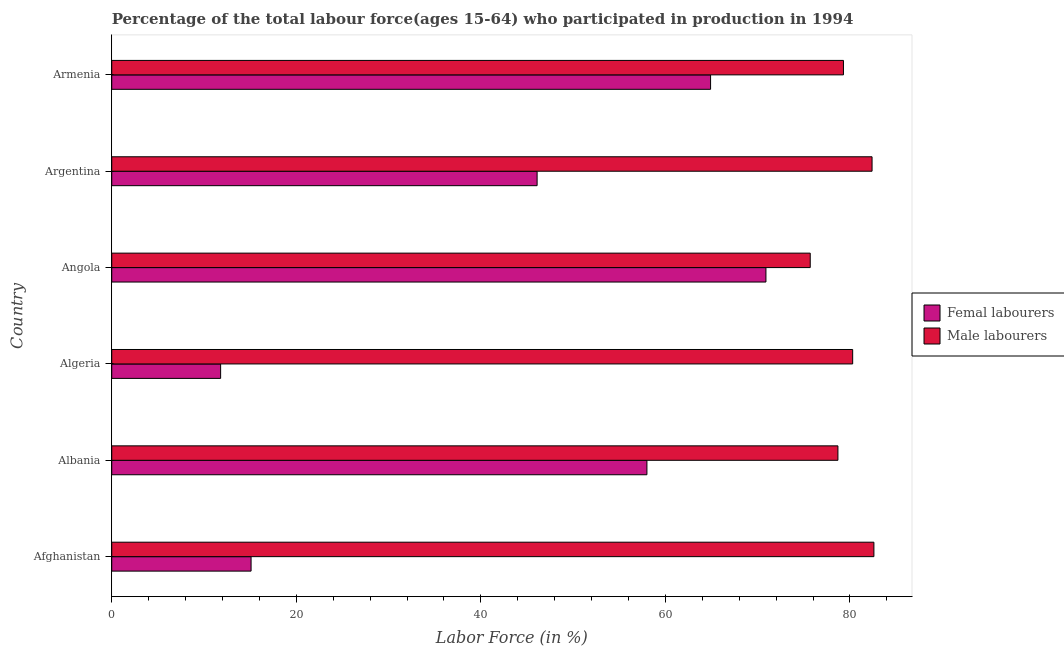Are the number of bars on each tick of the Y-axis equal?
Make the answer very short. Yes. How many bars are there on the 2nd tick from the top?
Give a very brief answer. 2. What is the label of the 3rd group of bars from the top?
Keep it short and to the point. Angola. What is the percentage of male labour force in Afghanistan?
Offer a terse response. 82.6. Across all countries, what is the maximum percentage of male labour force?
Ensure brevity in your answer.  82.6. Across all countries, what is the minimum percentage of male labour force?
Your answer should be compact. 75.7. In which country was the percentage of female labor force maximum?
Offer a terse response. Angola. In which country was the percentage of male labour force minimum?
Your answer should be compact. Angola. What is the total percentage of female labor force in the graph?
Keep it short and to the point. 266.8. What is the difference between the percentage of male labour force in Albania and that in Angola?
Give a very brief answer. 3. What is the difference between the percentage of female labor force in Argentina and the percentage of male labour force in Armenia?
Make the answer very short. -33.2. What is the average percentage of female labor force per country?
Offer a terse response. 44.47. What is the difference between the percentage of female labor force and percentage of male labour force in Argentina?
Keep it short and to the point. -36.3. What is the ratio of the percentage of female labor force in Algeria to that in Armenia?
Your response must be concise. 0.18. Is the percentage of male labour force in Algeria less than that in Argentina?
Ensure brevity in your answer.  Yes. Is the difference between the percentage of male labour force in Algeria and Armenia greater than the difference between the percentage of female labor force in Algeria and Armenia?
Offer a very short reply. Yes. What is the difference between the highest and the lowest percentage of male labour force?
Make the answer very short. 6.9. In how many countries, is the percentage of male labour force greater than the average percentage of male labour force taken over all countries?
Give a very brief answer. 3. What does the 2nd bar from the top in Argentina represents?
Give a very brief answer. Femal labourers. What does the 2nd bar from the bottom in Afghanistan represents?
Ensure brevity in your answer.  Male labourers. Are the values on the major ticks of X-axis written in scientific E-notation?
Offer a very short reply. No. How are the legend labels stacked?
Make the answer very short. Vertical. What is the title of the graph?
Offer a very short reply. Percentage of the total labour force(ages 15-64) who participated in production in 1994. Does "Under five" appear as one of the legend labels in the graph?
Make the answer very short. No. What is the label or title of the X-axis?
Keep it short and to the point. Labor Force (in %). What is the Labor Force (in %) in Femal labourers in Afghanistan?
Keep it short and to the point. 15.1. What is the Labor Force (in %) in Male labourers in Afghanistan?
Keep it short and to the point. 82.6. What is the Labor Force (in %) of Male labourers in Albania?
Provide a short and direct response. 78.7. What is the Labor Force (in %) of Femal labourers in Algeria?
Your answer should be very brief. 11.8. What is the Labor Force (in %) in Male labourers in Algeria?
Provide a short and direct response. 80.3. What is the Labor Force (in %) of Femal labourers in Angola?
Your response must be concise. 70.9. What is the Labor Force (in %) in Male labourers in Angola?
Give a very brief answer. 75.7. What is the Labor Force (in %) in Femal labourers in Argentina?
Your answer should be compact. 46.1. What is the Labor Force (in %) in Male labourers in Argentina?
Provide a succinct answer. 82.4. What is the Labor Force (in %) of Femal labourers in Armenia?
Provide a succinct answer. 64.9. What is the Labor Force (in %) in Male labourers in Armenia?
Your answer should be compact. 79.3. Across all countries, what is the maximum Labor Force (in %) in Femal labourers?
Your answer should be very brief. 70.9. Across all countries, what is the maximum Labor Force (in %) of Male labourers?
Make the answer very short. 82.6. Across all countries, what is the minimum Labor Force (in %) of Femal labourers?
Give a very brief answer. 11.8. Across all countries, what is the minimum Labor Force (in %) in Male labourers?
Your answer should be compact. 75.7. What is the total Labor Force (in %) of Femal labourers in the graph?
Your response must be concise. 266.8. What is the total Labor Force (in %) of Male labourers in the graph?
Provide a short and direct response. 479. What is the difference between the Labor Force (in %) in Femal labourers in Afghanistan and that in Albania?
Your response must be concise. -42.9. What is the difference between the Labor Force (in %) in Femal labourers in Afghanistan and that in Algeria?
Keep it short and to the point. 3.3. What is the difference between the Labor Force (in %) of Male labourers in Afghanistan and that in Algeria?
Your response must be concise. 2.3. What is the difference between the Labor Force (in %) in Femal labourers in Afghanistan and that in Angola?
Keep it short and to the point. -55.8. What is the difference between the Labor Force (in %) in Femal labourers in Afghanistan and that in Argentina?
Your answer should be very brief. -31. What is the difference between the Labor Force (in %) in Male labourers in Afghanistan and that in Argentina?
Offer a terse response. 0.2. What is the difference between the Labor Force (in %) of Femal labourers in Afghanistan and that in Armenia?
Your answer should be very brief. -49.8. What is the difference between the Labor Force (in %) of Femal labourers in Albania and that in Algeria?
Provide a succinct answer. 46.2. What is the difference between the Labor Force (in %) of Male labourers in Albania and that in Algeria?
Make the answer very short. -1.6. What is the difference between the Labor Force (in %) of Femal labourers in Albania and that in Angola?
Provide a short and direct response. -12.9. What is the difference between the Labor Force (in %) of Male labourers in Albania and that in Angola?
Your answer should be very brief. 3. What is the difference between the Labor Force (in %) of Femal labourers in Albania and that in Argentina?
Your answer should be compact. 11.9. What is the difference between the Labor Force (in %) of Femal labourers in Albania and that in Armenia?
Give a very brief answer. -6.9. What is the difference between the Labor Force (in %) of Male labourers in Albania and that in Armenia?
Provide a short and direct response. -0.6. What is the difference between the Labor Force (in %) of Femal labourers in Algeria and that in Angola?
Provide a succinct answer. -59.1. What is the difference between the Labor Force (in %) in Femal labourers in Algeria and that in Argentina?
Give a very brief answer. -34.3. What is the difference between the Labor Force (in %) of Femal labourers in Algeria and that in Armenia?
Make the answer very short. -53.1. What is the difference between the Labor Force (in %) of Femal labourers in Angola and that in Argentina?
Keep it short and to the point. 24.8. What is the difference between the Labor Force (in %) of Male labourers in Angola and that in Argentina?
Ensure brevity in your answer.  -6.7. What is the difference between the Labor Force (in %) in Femal labourers in Angola and that in Armenia?
Offer a terse response. 6. What is the difference between the Labor Force (in %) of Male labourers in Angola and that in Armenia?
Offer a very short reply. -3.6. What is the difference between the Labor Force (in %) in Femal labourers in Argentina and that in Armenia?
Ensure brevity in your answer.  -18.8. What is the difference between the Labor Force (in %) in Femal labourers in Afghanistan and the Labor Force (in %) in Male labourers in Albania?
Provide a succinct answer. -63.6. What is the difference between the Labor Force (in %) of Femal labourers in Afghanistan and the Labor Force (in %) of Male labourers in Algeria?
Your answer should be very brief. -65.2. What is the difference between the Labor Force (in %) of Femal labourers in Afghanistan and the Labor Force (in %) of Male labourers in Angola?
Offer a terse response. -60.6. What is the difference between the Labor Force (in %) in Femal labourers in Afghanistan and the Labor Force (in %) in Male labourers in Argentina?
Keep it short and to the point. -67.3. What is the difference between the Labor Force (in %) of Femal labourers in Afghanistan and the Labor Force (in %) of Male labourers in Armenia?
Keep it short and to the point. -64.2. What is the difference between the Labor Force (in %) in Femal labourers in Albania and the Labor Force (in %) in Male labourers in Algeria?
Keep it short and to the point. -22.3. What is the difference between the Labor Force (in %) in Femal labourers in Albania and the Labor Force (in %) in Male labourers in Angola?
Provide a succinct answer. -17.7. What is the difference between the Labor Force (in %) in Femal labourers in Albania and the Labor Force (in %) in Male labourers in Argentina?
Ensure brevity in your answer.  -24.4. What is the difference between the Labor Force (in %) in Femal labourers in Albania and the Labor Force (in %) in Male labourers in Armenia?
Ensure brevity in your answer.  -21.3. What is the difference between the Labor Force (in %) in Femal labourers in Algeria and the Labor Force (in %) in Male labourers in Angola?
Give a very brief answer. -63.9. What is the difference between the Labor Force (in %) of Femal labourers in Algeria and the Labor Force (in %) of Male labourers in Argentina?
Offer a terse response. -70.6. What is the difference between the Labor Force (in %) of Femal labourers in Algeria and the Labor Force (in %) of Male labourers in Armenia?
Your answer should be very brief. -67.5. What is the difference between the Labor Force (in %) in Femal labourers in Angola and the Labor Force (in %) in Male labourers in Argentina?
Make the answer very short. -11.5. What is the difference between the Labor Force (in %) of Femal labourers in Angola and the Labor Force (in %) of Male labourers in Armenia?
Offer a terse response. -8.4. What is the difference between the Labor Force (in %) of Femal labourers in Argentina and the Labor Force (in %) of Male labourers in Armenia?
Your response must be concise. -33.2. What is the average Labor Force (in %) in Femal labourers per country?
Provide a succinct answer. 44.47. What is the average Labor Force (in %) in Male labourers per country?
Ensure brevity in your answer.  79.83. What is the difference between the Labor Force (in %) of Femal labourers and Labor Force (in %) of Male labourers in Afghanistan?
Provide a succinct answer. -67.5. What is the difference between the Labor Force (in %) of Femal labourers and Labor Force (in %) of Male labourers in Albania?
Provide a short and direct response. -20.7. What is the difference between the Labor Force (in %) of Femal labourers and Labor Force (in %) of Male labourers in Algeria?
Give a very brief answer. -68.5. What is the difference between the Labor Force (in %) in Femal labourers and Labor Force (in %) in Male labourers in Argentina?
Your answer should be compact. -36.3. What is the difference between the Labor Force (in %) of Femal labourers and Labor Force (in %) of Male labourers in Armenia?
Your response must be concise. -14.4. What is the ratio of the Labor Force (in %) in Femal labourers in Afghanistan to that in Albania?
Give a very brief answer. 0.26. What is the ratio of the Labor Force (in %) in Male labourers in Afghanistan to that in Albania?
Your response must be concise. 1.05. What is the ratio of the Labor Force (in %) of Femal labourers in Afghanistan to that in Algeria?
Ensure brevity in your answer.  1.28. What is the ratio of the Labor Force (in %) in Male labourers in Afghanistan to that in Algeria?
Keep it short and to the point. 1.03. What is the ratio of the Labor Force (in %) in Femal labourers in Afghanistan to that in Angola?
Provide a short and direct response. 0.21. What is the ratio of the Labor Force (in %) in Male labourers in Afghanistan to that in Angola?
Your response must be concise. 1.09. What is the ratio of the Labor Force (in %) in Femal labourers in Afghanistan to that in Argentina?
Make the answer very short. 0.33. What is the ratio of the Labor Force (in %) of Male labourers in Afghanistan to that in Argentina?
Your answer should be very brief. 1. What is the ratio of the Labor Force (in %) in Femal labourers in Afghanistan to that in Armenia?
Keep it short and to the point. 0.23. What is the ratio of the Labor Force (in %) in Male labourers in Afghanistan to that in Armenia?
Keep it short and to the point. 1.04. What is the ratio of the Labor Force (in %) of Femal labourers in Albania to that in Algeria?
Your answer should be compact. 4.92. What is the ratio of the Labor Force (in %) of Male labourers in Albania to that in Algeria?
Make the answer very short. 0.98. What is the ratio of the Labor Force (in %) in Femal labourers in Albania to that in Angola?
Your response must be concise. 0.82. What is the ratio of the Labor Force (in %) of Male labourers in Albania to that in Angola?
Your answer should be compact. 1.04. What is the ratio of the Labor Force (in %) in Femal labourers in Albania to that in Argentina?
Your answer should be compact. 1.26. What is the ratio of the Labor Force (in %) in Male labourers in Albania to that in Argentina?
Offer a terse response. 0.96. What is the ratio of the Labor Force (in %) in Femal labourers in Albania to that in Armenia?
Provide a short and direct response. 0.89. What is the ratio of the Labor Force (in %) of Male labourers in Albania to that in Armenia?
Your answer should be very brief. 0.99. What is the ratio of the Labor Force (in %) of Femal labourers in Algeria to that in Angola?
Provide a short and direct response. 0.17. What is the ratio of the Labor Force (in %) of Male labourers in Algeria to that in Angola?
Give a very brief answer. 1.06. What is the ratio of the Labor Force (in %) in Femal labourers in Algeria to that in Argentina?
Ensure brevity in your answer.  0.26. What is the ratio of the Labor Force (in %) in Male labourers in Algeria to that in Argentina?
Provide a short and direct response. 0.97. What is the ratio of the Labor Force (in %) in Femal labourers in Algeria to that in Armenia?
Keep it short and to the point. 0.18. What is the ratio of the Labor Force (in %) of Male labourers in Algeria to that in Armenia?
Provide a short and direct response. 1.01. What is the ratio of the Labor Force (in %) of Femal labourers in Angola to that in Argentina?
Make the answer very short. 1.54. What is the ratio of the Labor Force (in %) in Male labourers in Angola to that in Argentina?
Your answer should be compact. 0.92. What is the ratio of the Labor Force (in %) of Femal labourers in Angola to that in Armenia?
Offer a terse response. 1.09. What is the ratio of the Labor Force (in %) in Male labourers in Angola to that in Armenia?
Offer a very short reply. 0.95. What is the ratio of the Labor Force (in %) of Femal labourers in Argentina to that in Armenia?
Make the answer very short. 0.71. What is the ratio of the Labor Force (in %) in Male labourers in Argentina to that in Armenia?
Offer a very short reply. 1.04. What is the difference between the highest and the second highest Labor Force (in %) in Male labourers?
Ensure brevity in your answer.  0.2. What is the difference between the highest and the lowest Labor Force (in %) of Femal labourers?
Give a very brief answer. 59.1. 